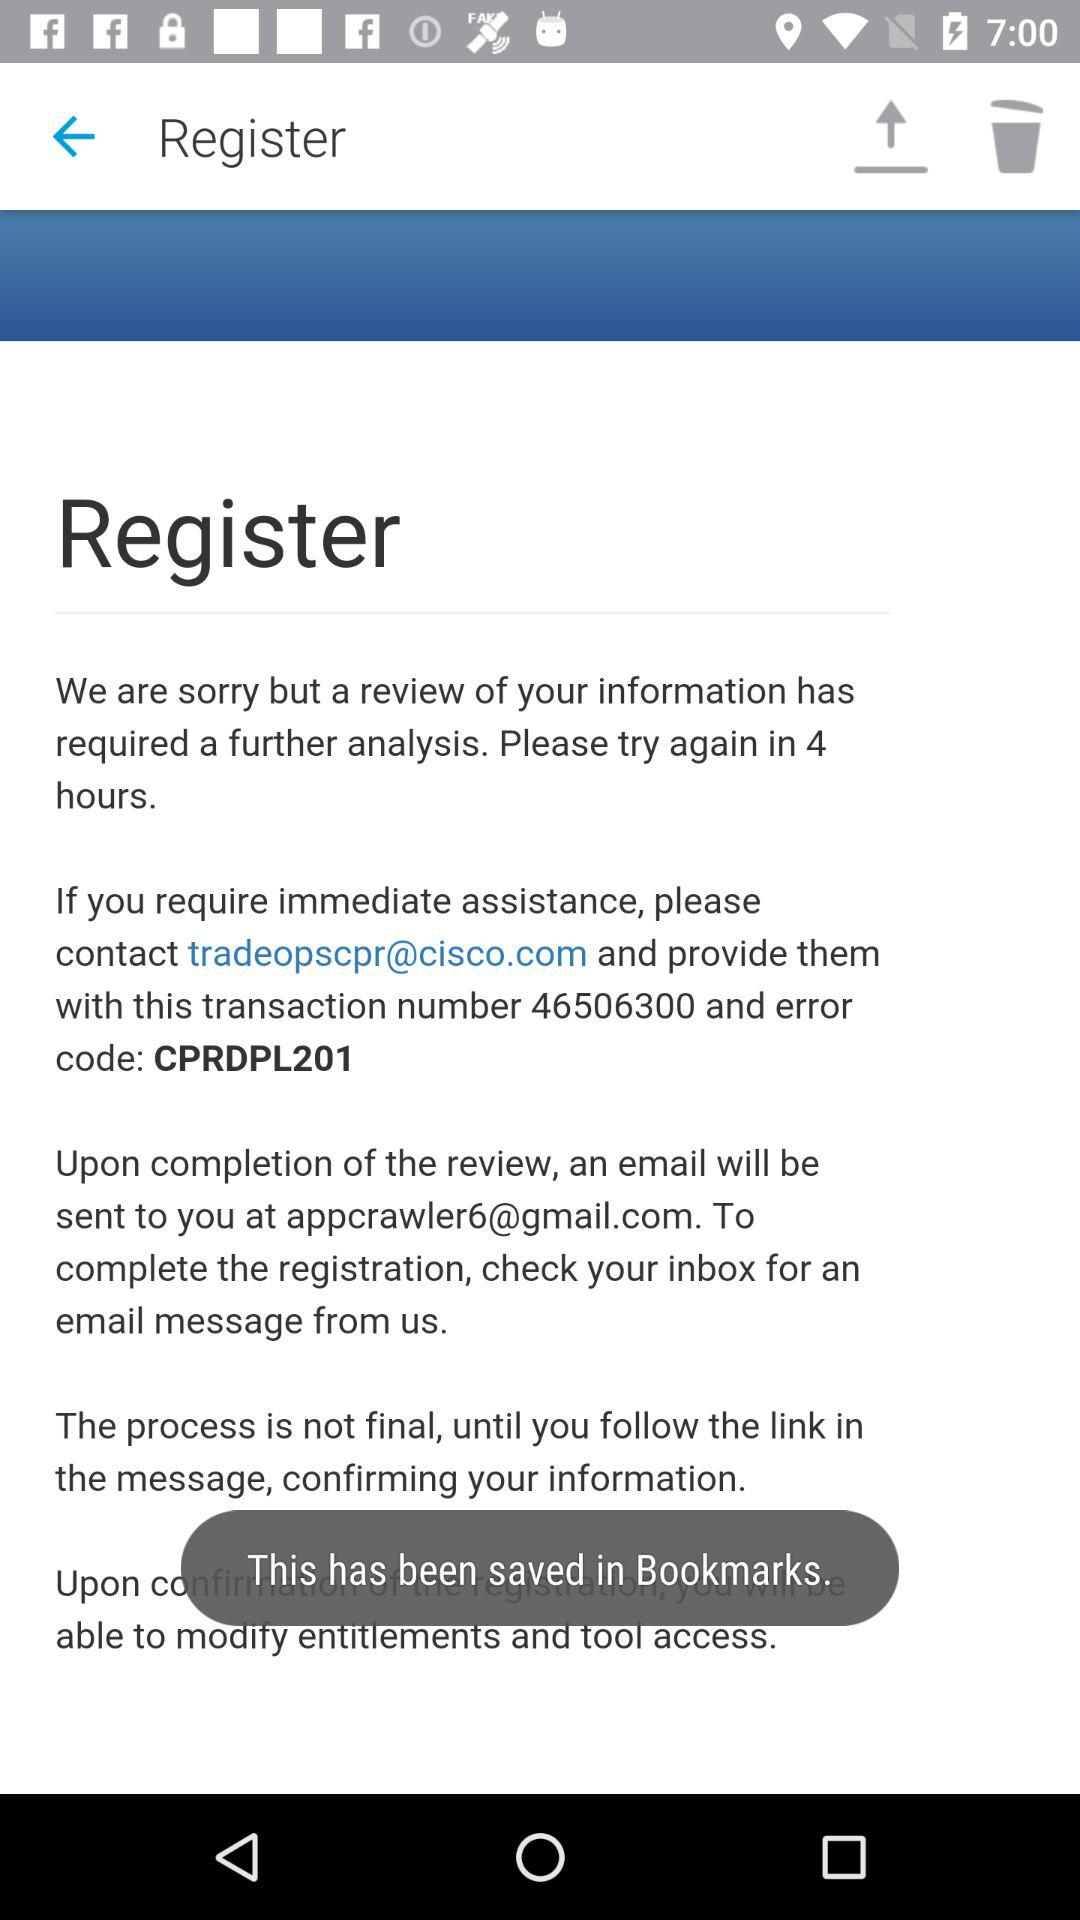For immediate assistance, what email address is provided? The email address is tradeopscpr@cisco.com. 